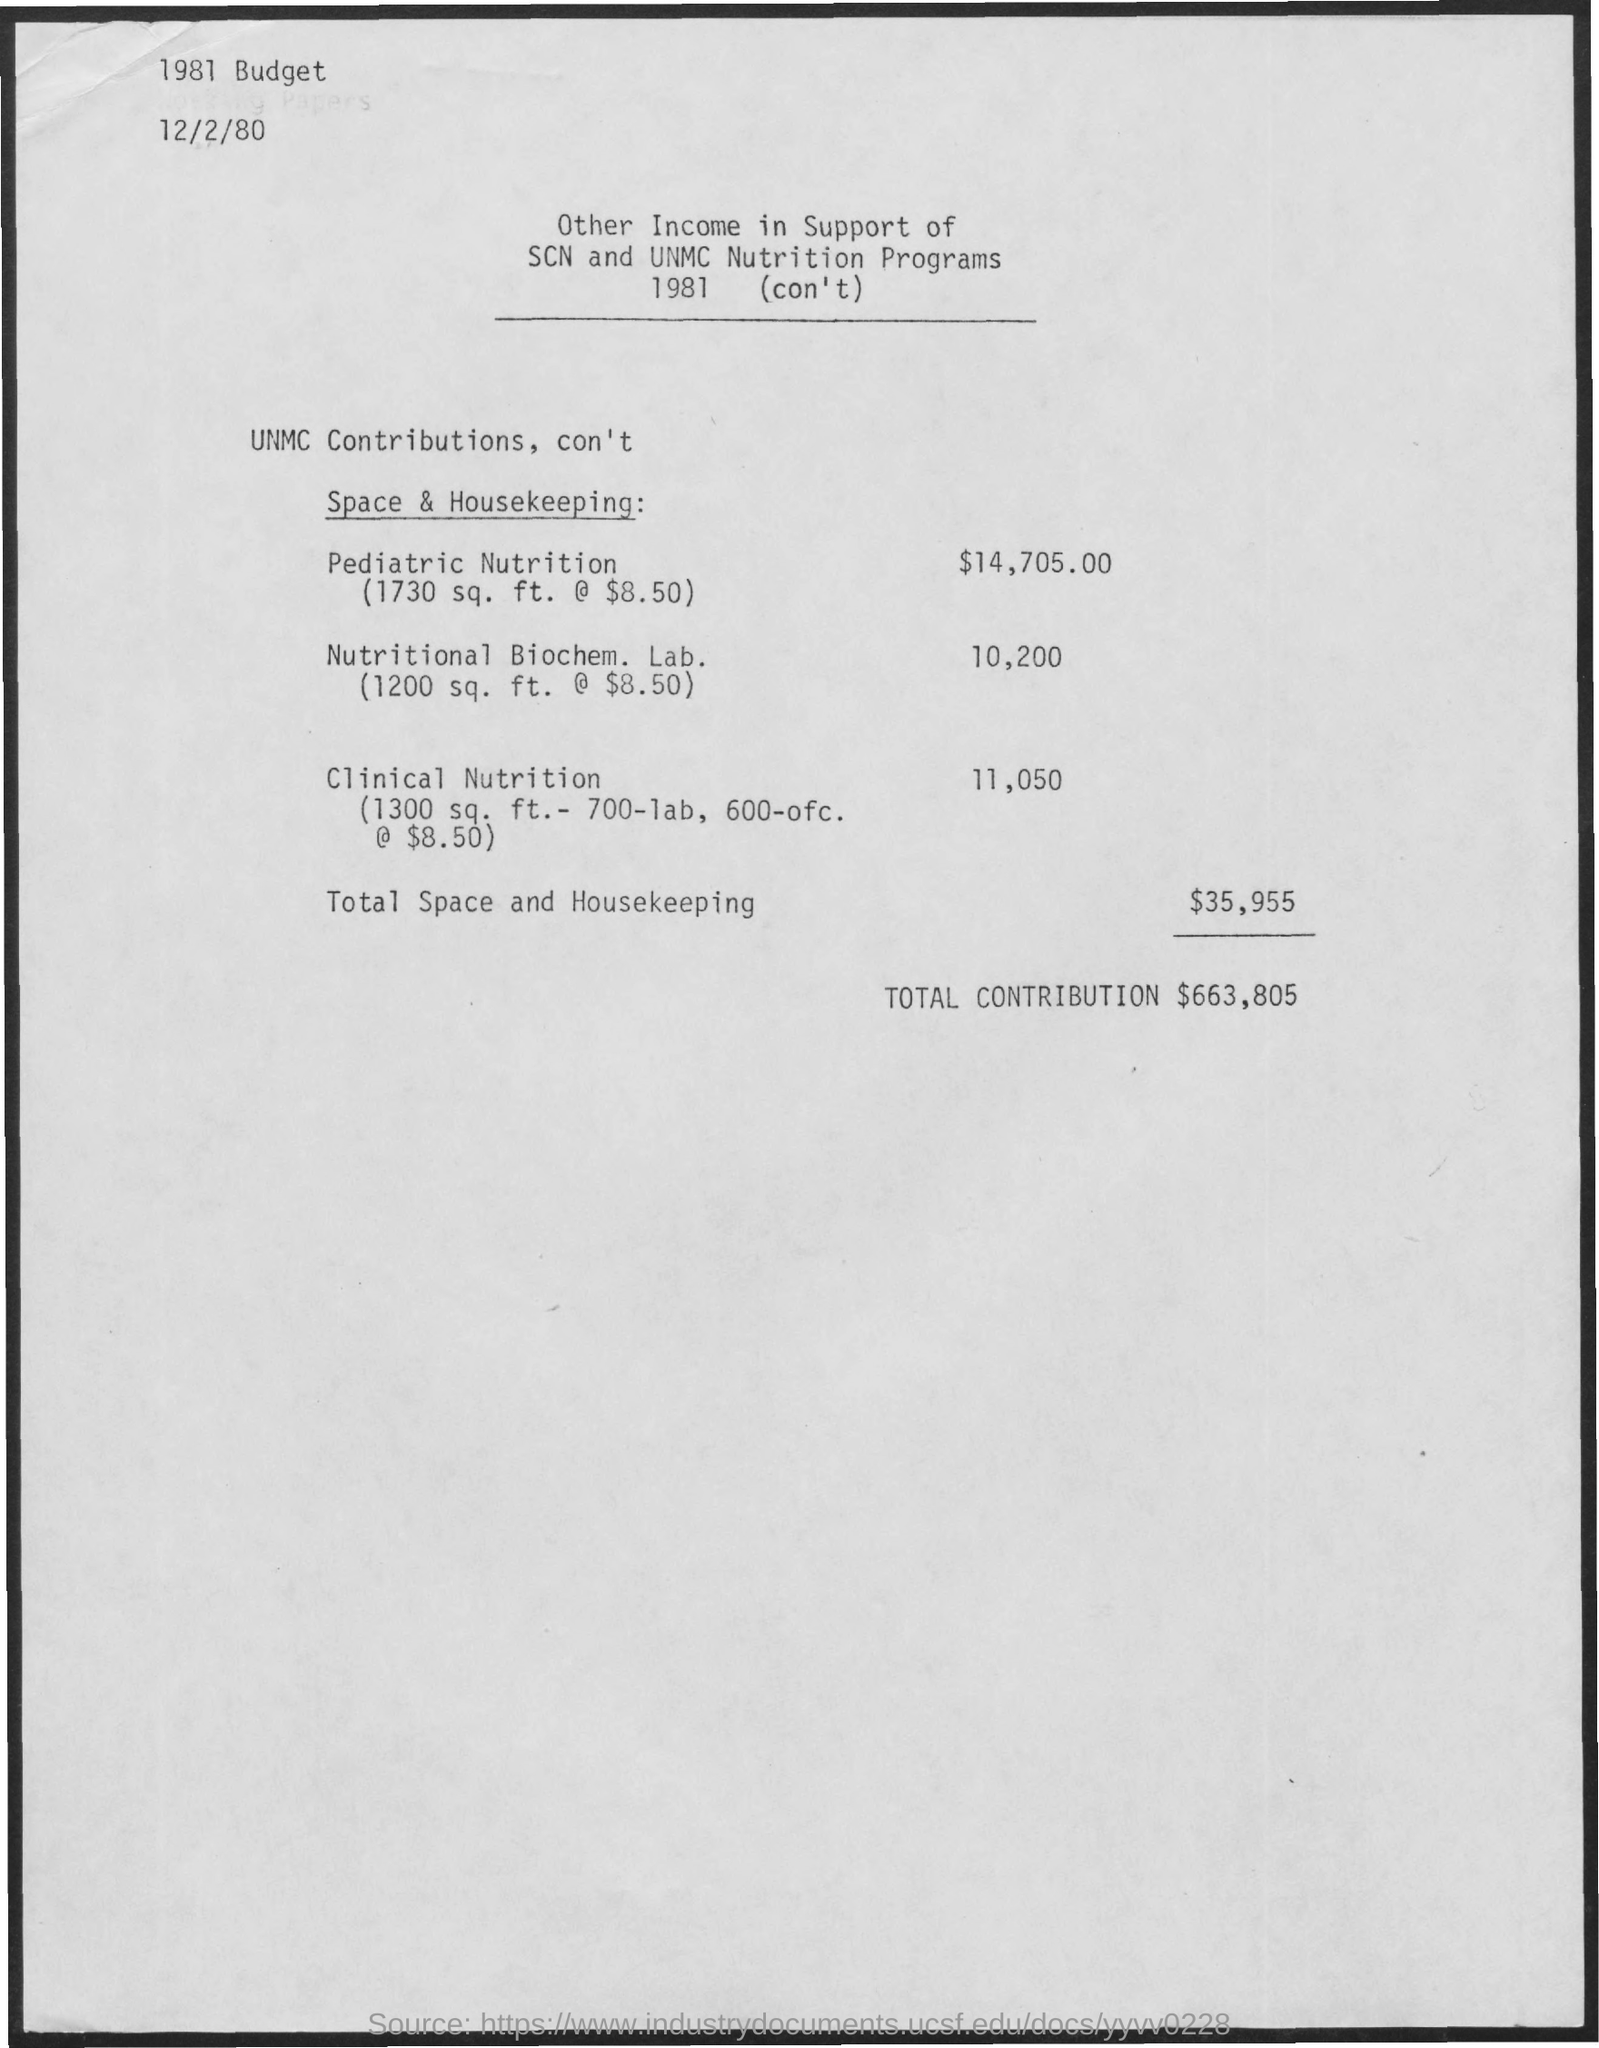Point out several critical features in this image. The total income received from space and housekeeping is $35,955. The income contributed by the Nutritional Biochemistry Laboratory is 10,200. The year of the budget mentioned in the top left corner of the page is 1981. The area covered by "pediatric nutrition" is approximately 1730 square feet. The date on the top of the page is December 2nd, 1980. 